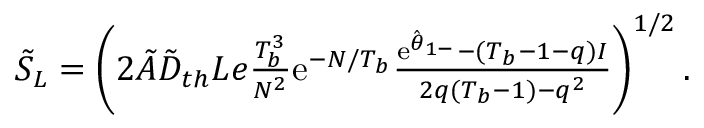<formula> <loc_0><loc_0><loc_500><loc_500>\begin{array} { r } { \tilde { S } _ { L } = \left ( 2 \tilde { A } \tilde { D } _ { t h } L e \frac { T _ { b } ^ { 3 } } { N ^ { 2 } } e ^ { - N / T _ { b } } \frac { e ^ { \hat { \theta } _ { 1 - } } - ( T _ { b } - 1 - q ) I } { 2 q ( T _ { b } - 1 ) - q ^ { 2 } } \right ) ^ { 1 / 2 } . } \end{array}</formula> 